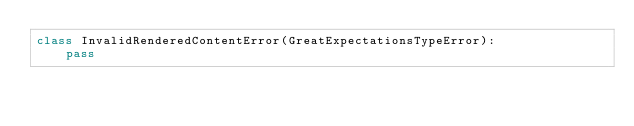Convert code to text. <code><loc_0><loc_0><loc_500><loc_500><_Python_>class InvalidRenderedContentError(GreatExpectationsTypeError):
    pass
</code> 